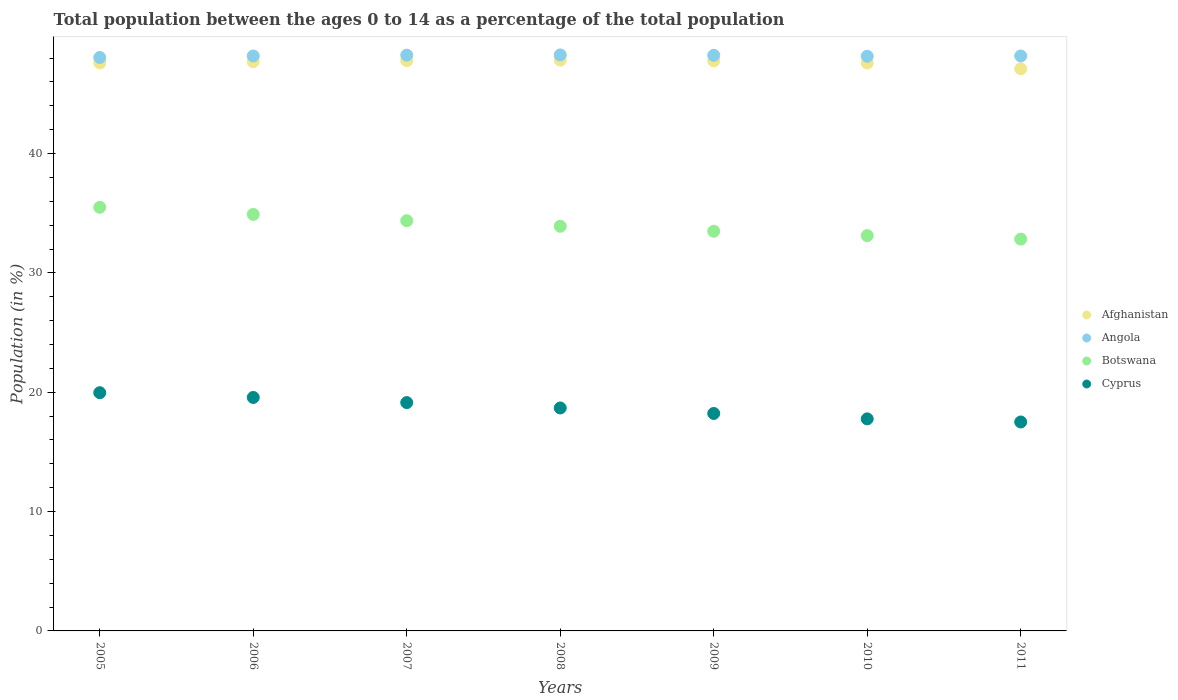What is the percentage of the population ages 0 to 14 in Botswana in 2006?
Your response must be concise. 34.9. Across all years, what is the maximum percentage of the population ages 0 to 14 in Angola?
Offer a terse response. 48.27. Across all years, what is the minimum percentage of the population ages 0 to 14 in Afghanistan?
Your answer should be compact. 47.1. What is the total percentage of the population ages 0 to 14 in Botswana in the graph?
Make the answer very short. 238.13. What is the difference between the percentage of the population ages 0 to 14 in Angola in 2006 and that in 2010?
Give a very brief answer. 0.03. What is the difference between the percentage of the population ages 0 to 14 in Cyprus in 2010 and the percentage of the population ages 0 to 14 in Angola in 2007?
Provide a short and direct response. -30.48. What is the average percentage of the population ages 0 to 14 in Angola per year?
Give a very brief answer. 48.19. In the year 2006, what is the difference between the percentage of the population ages 0 to 14 in Afghanistan and percentage of the population ages 0 to 14 in Botswana?
Your answer should be compact. 12.8. What is the ratio of the percentage of the population ages 0 to 14 in Botswana in 2005 to that in 2010?
Give a very brief answer. 1.07. Is the difference between the percentage of the population ages 0 to 14 in Afghanistan in 2010 and 2011 greater than the difference between the percentage of the population ages 0 to 14 in Botswana in 2010 and 2011?
Keep it short and to the point. Yes. What is the difference between the highest and the second highest percentage of the population ages 0 to 14 in Afghanistan?
Keep it short and to the point. 0.04. What is the difference between the highest and the lowest percentage of the population ages 0 to 14 in Botswana?
Make the answer very short. 2.67. Is the sum of the percentage of the population ages 0 to 14 in Botswana in 2008 and 2009 greater than the maximum percentage of the population ages 0 to 14 in Afghanistan across all years?
Your response must be concise. Yes. Is it the case that in every year, the sum of the percentage of the population ages 0 to 14 in Angola and percentage of the population ages 0 to 14 in Cyprus  is greater than the sum of percentage of the population ages 0 to 14 in Botswana and percentage of the population ages 0 to 14 in Afghanistan?
Offer a terse response. No. Is the percentage of the population ages 0 to 14 in Cyprus strictly greater than the percentage of the population ages 0 to 14 in Afghanistan over the years?
Offer a very short reply. No. Is the percentage of the population ages 0 to 14 in Afghanistan strictly less than the percentage of the population ages 0 to 14 in Angola over the years?
Your answer should be compact. Yes. How many years are there in the graph?
Provide a short and direct response. 7. What is the difference between two consecutive major ticks on the Y-axis?
Make the answer very short. 10. Are the values on the major ticks of Y-axis written in scientific E-notation?
Keep it short and to the point. No. Where does the legend appear in the graph?
Give a very brief answer. Center right. How many legend labels are there?
Offer a very short reply. 4. How are the legend labels stacked?
Make the answer very short. Vertical. What is the title of the graph?
Make the answer very short. Total population between the ages 0 to 14 as a percentage of the total population. What is the label or title of the X-axis?
Give a very brief answer. Years. What is the label or title of the Y-axis?
Provide a succinct answer. Population (in %). What is the Population (in %) in Afghanistan in 2005?
Your response must be concise. 47.59. What is the Population (in %) of Angola in 2005?
Provide a short and direct response. 48.05. What is the Population (in %) in Botswana in 2005?
Offer a very short reply. 35.5. What is the Population (in %) in Cyprus in 2005?
Keep it short and to the point. 19.96. What is the Population (in %) in Afghanistan in 2006?
Offer a very short reply. 47.7. What is the Population (in %) of Angola in 2006?
Ensure brevity in your answer.  48.18. What is the Population (in %) in Botswana in 2006?
Offer a terse response. 34.9. What is the Population (in %) in Cyprus in 2006?
Provide a short and direct response. 19.56. What is the Population (in %) in Afghanistan in 2007?
Provide a succinct answer. 47.79. What is the Population (in %) in Angola in 2007?
Offer a very short reply. 48.25. What is the Population (in %) in Botswana in 2007?
Offer a very short reply. 34.37. What is the Population (in %) of Cyprus in 2007?
Offer a very short reply. 19.13. What is the Population (in %) in Afghanistan in 2008?
Make the answer very short. 47.83. What is the Population (in %) in Angola in 2008?
Provide a short and direct response. 48.27. What is the Population (in %) in Botswana in 2008?
Give a very brief answer. 33.91. What is the Population (in %) in Cyprus in 2008?
Your answer should be very brief. 18.68. What is the Population (in %) in Afghanistan in 2009?
Ensure brevity in your answer.  47.77. What is the Population (in %) in Angola in 2009?
Your answer should be compact. 48.23. What is the Population (in %) in Botswana in 2009?
Ensure brevity in your answer.  33.49. What is the Population (in %) of Cyprus in 2009?
Your answer should be compact. 18.22. What is the Population (in %) in Afghanistan in 2010?
Provide a succinct answer. 47.59. What is the Population (in %) in Angola in 2010?
Your answer should be compact. 48.15. What is the Population (in %) of Botswana in 2010?
Ensure brevity in your answer.  33.12. What is the Population (in %) of Cyprus in 2010?
Provide a succinct answer. 17.77. What is the Population (in %) of Afghanistan in 2011?
Provide a succinct answer. 47.1. What is the Population (in %) in Angola in 2011?
Offer a very short reply. 48.18. What is the Population (in %) in Botswana in 2011?
Offer a terse response. 32.83. What is the Population (in %) of Cyprus in 2011?
Your response must be concise. 17.51. Across all years, what is the maximum Population (in %) of Afghanistan?
Provide a short and direct response. 47.83. Across all years, what is the maximum Population (in %) in Angola?
Offer a terse response. 48.27. Across all years, what is the maximum Population (in %) of Botswana?
Your response must be concise. 35.5. Across all years, what is the maximum Population (in %) in Cyprus?
Give a very brief answer. 19.96. Across all years, what is the minimum Population (in %) in Afghanistan?
Your answer should be very brief. 47.1. Across all years, what is the minimum Population (in %) of Angola?
Ensure brevity in your answer.  48.05. Across all years, what is the minimum Population (in %) of Botswana?
Make the answer very short. 32.83. Across all years, what is the minimum Population (in %) of Cyprus?
Offer a very short reply. 17.51. What is the total Population (in %) in Afghanistan in the graph?
Make the answer very short. 333.36. What is the total Population (in %) of Angola in the graph?
Ensure brevity in your answer.  337.31. What is the total Population (in %) in Botswana in the graph?
Your answer should be compact. 238.13. What is the total Population (in %) in Cyprus in the graph?
Your response must be concise. 130.84. What is the difference between the Population (in %) in Afghanistan in 2005 and that in 2006?
Keep it short and to the point. -0.1. What is the difference between the Population (in %) in Angola in 2005 and that in 2006?
Your response must be concise. -0.13. What is the difference between the Population (in %) of Botswana in 2005 and that in 2006?
Your response must be concise. 0.59. What is the difference between the Population (in %) in Cyprus in 2005 and that in 2006?
Offer a terse response. 0.4. What is the difference between the Population (in %) in Afghanistan in 2005 and that in 2007?
Offer a very short reply. -0.19. What is the difference between the Population (in %) in Angola in 2005 and that in 2007?
Your answer should be very brief. -0.2. What is the difference between the Population (in %) of Botswana in 2005 and that in 2007?
Ensure brevity in your answer.  1.12. What is the difference between the Population (in %) of Cyprus in 2005 and that in 2007?
Your answer should be very brief. 0.83. What is the difference between the Population (in %) of Afghanistan in 2005 and that in 2008?
Provide a short and direct response. -0.23. What is the difference between the Population (in %) in Angola in 2005 and that in 2008?
Give a very brief answer. -0.22. What is the difference between the Population (in %) in Botswana in 2005 and that in 2008?
Ensure brevity in your answer.  1.59. What is the difference between the Population (in %) of Cyprus in 2005 and that in 2008?
Offer a very short reply. 1.28. What is the difference between the Population (in %) of Afghanistan in 2005 and that in 2009?
Your answer should be compact. -0.17. What is the difference between the Population (in %) in Angola in 2005 and that in 2009?
Offer a very short reply. -0.18. What is the difference between the Population (in %) of Botswana in 2005 and that in 2009?
Your response must be concise. 2. What is the difference between the Population (in %) of Cyprus in 2005 and that in 2009?
Give a very brief answer. 1.74. What is the difference between the Population (in %) of Afghanistan in 2005 and that in 2010?
Offer a terse response. 0. What is the difference between the Population (in %) of Angola in 2005 and that in 2010?
Ensure brevity in your answer.  -0.1. What is the difference between the Population (in %) of Botswana in 2005 and that in 2010?
Provide a short and direct response. 2.37. What is the difference between the Population (in %) of Cyprus in 2005 and that in 2010?
Your answer should be very brief. 2.19. What is the difference between the Population (in %) in Afghanistan in 2005 and that in 2011?
Offer a terse response. 0.49. What is the difference between the Population (in %) of Angola in 2005 and that in 2011?
Give a very brief answer. -0.13. What is the difference between the Population (in %) in Botswana in 2005 and that in 2011?
Keep it short and to the point. 2.67. What is the difference between the Population (in %) of Cyprus in 2005 and that in 2011?
Keep it short and to the point. 2.45. What is the difference between the Population (in %) in Afghanistan in 2006 and that in 2007?
Offer a terse response. -0.09. What is the difference between the Population (in %) of Angola in 2006 and that in 2007?
Your answer should be very brief. -0.07. What is the difference between the Population (in %) in Botswana in 2006 and that in 2007?
Provide a short and direct response. 0.53. What is the difference between the Population (in %) of Cyprus in 2006 and that in 2007?
Offer a very short reply. 0.43. What is the difference between the Population (in %) of Afghanistan in 2006 and that in 2008?
Keep it short and to the point. -0.13. What is the difference between the Population (in %) in Angola in 2006 and that in 2008?
Keep it short and to the point. -0.09. What is the difference between the Population (in %) in Afghanistan in 2006 and that in 2009?
Make the answer very short. -0.07. What is the difference between the Population (in %) in Angola in 2006 and that in 2009?
Give a very brief answer. -0.06. What is the difference between the Population (in %) in Botswana in 2006 and that in 2009?
Offer a very short reply. 1.41. What is the difference between the Population (in %) in Cyprus in 2006 and that in 2009?
Give a very brief answer. 1.34. What is the difference between the Population (in %) in Afghanistan in 2006 and that in 2010?
Give a very brief answer. 0.11. What is the difference between the Population (in %) in Angola in 2006 and that in 2010?
Offer a very short reply. 0.03. What is the difference between the Population (in %) of Botswana in 2006 and that in 2010?
Provide a succinct answer. 1.78. What is the difference between the Population (in %) of Cyprus in 2006 and that in 2010?
Your response must be concise. 1.79. What is the difference between the Population (in %) of Afghanistan in 2006 and that in 2011?
Your answer should be compact. 0.6. What is the difference between the Population (in %) of Angola in 2006 and that in 2011?
Your answer should be compact. -0. What is the difference between the Population (in %) of Botswana in 2006 and that in 2011?
Provide a succinct answer. 2.07. What is the difference between the Population (in %) in Cyprus in 2006 and that in 2011?
Offer a terse response. 2.05. What is the difference between the Population (in %) in Afghanistan in 2007 and that in 2008?
Offer a very short reply. -0.04. What is the difference between the Population (in %) of Angola in 2007 and that in 2008?
Give a very brief answer. -0.02. What is the difference between the Population (in %) of Botswana in 2007 and that in 2008?
Your response must be concise. 0.47. What is the difference between the Population (in %) of Cyprus in 2007 and that in 2008?
Your response must be concise. 0.45. What is the difference between the Population (in %) of Afghanistan in 2007 and that in 2009?
Your answer should be very brief. 0.02. What is the difference between the Population (in %) of Angola in 2007 and that in 2009?
Your answer should be compact. 0.01. What is the difference between the Population (in %) in Botswana in 2007 and that in 2009?
Keep it short and to the point. 0.88. What is the difference between the Population (in %) in Cyprus in 2007 and that in 2009?
Your response must be concise. 0.91. What is the difference between the Population (in %) of Afghanistan in 2007 and that in 2010?
Offer a terse response. 0.2. What is the difference between the Population (in %) of Angola in 2007 and that in 2010?
Your answer should be compact. 0.1. What is the difference between the Population (in %) in Botswana in 2007 and that in 2010?
Your response must be concise. 1.25. What is the difference between the Population (in %) of Cyprus in 2007 and that in 2010?
Offer a terse response. 1.36. What is the difference between the Population (in %) of Afghanistan in 2007 and that in 2011?
Your answer should be very brief. 0.69. What is the difference between the Population (in %) in Angola in 2007 and that in 2011?
Provide a short and direct response. 0.07. What is the difference between the Population (in %) in Botswana in 2007 and that in 2011?
Ensure brevity in your answer.  1.54. What is the difference between the Population (in %) of Cyprus in 2007 and that in 2011?
Offer a very short reply. 1.62. What is the difference between the Population (in %) in Afghanistan in 2008 and that in 2009?
Give a very brief answer. 0.06. What is the difference between the Population (in %) in Angola in 2008 and that in 2009?
Give a very brief answer. 0.03. What is the difference between the Population (in %) in Botswana in 2008 and that in 2009?
Your response must be concise. 0.42. What is the difference between the Population (in %) in Cyprus in 2008 and that in 2009?
Provide a succinct answer. 0.46. What is the difference between the Population (in %) of Afghanistan in 2008 and that in 2010?
Make the answer very short. 0.24. What is the difference between the Population (in %) of Angola in 2008 and that in 2010?
Your answer should be very brief. 0.11. What is the difference between the Population (in %) of Botswana in 2008 and that in 2010?
Offer a terse response. 0.78. What is the difference between the Population (in %) in Cyprus in 2008 and that in 2010?
Your answer should be compact. 0.91. What is the difference between the Population (in %) of Afghanistan in 2008 and that in 2011?
Your answer should be very brief. 0.72. What is the difference between the Population (in %) in Angola in 2008 and that in 2011?
Keep it short and to the point. 0.09. What is the difference between the Population (in %) of Botswana in 2008 and that in 2011?
Your response must be concise. 1.08. What is the difference between the Population (in %) of Cyprus in 2008 and that in 2011?
Ensure brevity in your answer.  1.17. What is the difference between the Population (in %) of Afghanistan in 2009 and that in 2010?
Provide a short and direct response. 0.18. What is the difference between the Population (in %) of Angola in 2009 and that in 2010?
Your answer should be compact. 0.08. What is the difference between the Population (in %) of Botswana in 2009 and that in 2010?
Your response must be concise. 0.37. What is the difference between the Population (in %) in Cyprus in 2009 and that in 2010?
Provide a succinct answer. 0.45. What is the difference between the Population (in %) in Afghanistan in 2009 and that in 2011?
Your answer should be very brief. 0.67. What is the difference between the Population (in %) in Angola in 2009 and that in 2011?
Give a very brief answer. 0.05. What is the difference between the Population (in %) of Botswana in 2009 and that in 2011?
Provide a succinct answer. 0.66. What is the difference between the Population (in %) of Cyprus in 2009 and that in 2011?
Provide a succinct answer. 0.71. What is the difference between the Population (in %) in Afghanistan in 2010 and that in 2011?
Give a very brief answer. 0.49. What is the difference between the Population (in %) of Angola in 2010 and that in 2011?
Keep it short and to the point. -0.03. What is the difference between the Population (in %) in Botswana in 2010 and that in 2011?
Your response must be concise. 0.29. What is the difference between the Population (in %) in Cyprus in 2010 and that in 2011?
Give a very brief answer. 0.26. What is the difference between the Population (in %) of Afghanistan in 2005 and the Population (in %) of Angola in 2006?
Your response must be concise. -0.59. What is the difference between the Population (in %) in Afghanistan in 2005 and the Population (in %) in Botswana in 2006?
Give a very brief answer. 12.69. What is the difference between the Population (in %) in Afghanistan in 2005 and the Population (in %) in Cyprus in 2006?
Keep it short and to the point. 28.03. What is the difference between the Population (in %) of Angola in 2005 and the Population (in %) of Botswana in 2006?
Make the answer very short. 13.15. What is the difference between the Population (in %) in Angola in 2005 and the Population (in %) in Cyprus in 2006?
Ensure brevity in your answer.  28.49. What is the difference between the Population (in %) in Botswana in 2005 and the Population (in %) in Cyprus in 2006?
Provide a short and direct response. 15.93. What is the difference between the Population (in %) of Afghanistan in 2005 and the Population (in %) of Angola in 2007?
Your answer should be compact. -0.66. What is the difference between the Population (in %) in Afghanistan in 2005 and the Population (in %) in Botswana in 2007?
Your response must be concise. 13.22. What is the difference between the Population (in %) of Afghanistan in 2005 and the Population (in %) of Cyprus in 2007?
Offer a terse response. 28.46. What is the difference between the Population (in %) of Angola in 2005 and the Population (in %) of Botswana in 2007?
Provide a short and direct response. 13.68. What is the difference between the Population (in %) of Angola in 2005 and the Population (in %) of Cyprus in 2007?
Make the answer very short. 28.92. What is the difference between the Population (in %) of Botswana in 2005 and the Population (in %) of Cyprus in 2007?
Your answer should be compact. 16.36. What is the difference between the Population (in %) of Afghanistan in 2005 and the Population (in %) of Angola in 2008?
Your response must be concise. -0.67. What is the difference between the Population (in %) in Afghanistan in 2005 and the Population (in %) in Botswana in 2008?
Your response must be concise. 13.69. What is the difference between the Population (in %) of Afghanistan in 2005 and the Population (in %) of Cyprus in 2008?
Give a very brief answer. 28.91. What is the difference between the Population (in %) of Angola in 2005 and the Population (in %) of Botswana in 2008?
Provide a short and direct response. 14.14. What is the difference between the Population (in %) in Angola in 2005 and the Population (in %) in Cyprus in 2008?
Give a very brief answer. 29.37. What is the difference between the Population (in %) in Botswana in 2005 and the Population (in %) in Cyprus in 2008?
Provide a short and direct response. 16.81. What is the difference between the Population (in %) in Afghanistan in 2005 and the Population (in %) in Angola in 2009?
Make the answer very short. -0.64. What is the difference between the Population (in %) in Afghanistan in 2005 and the Population (in %) in Botswana in 2009?
Offer a very short reply. 14.1. What is the difference between the Population (in %) of Afghanistan in 2005 and the Population (in %) of Cyprus in 2009?
Your response must be concise. 29.37. What is the difference between the Population (in %) of Angola in 2005 and the Population (in %) of Botswana in 2009?
Your answer should be compact. 14.56. What is the difference between the Population (in %) in Angola in 2005 and the Population (in %) in Cyprus in 2009?
Provide a succinct answer. 29.83. What is the difference between the Population (in %) of Botswana in 2005 and the Population (in %) of Cyprus in 2009?
Give a very brief answer. 17.27. What is the difference between the Population (in %) of Afghanistan in 2005 and the Population (in %) of Angola in 2010?
Provide a short and direct response. -0.56. What is the difference between the Population (in %) of Afghanistan in 2005 and the Population (in %) of Botswana in 2010?
Your answer should be compact. 14.47. What is the difference between the Population (in %) of Afghanistan in 2005 and the Population (in %) of Cyprus in 2010?
Offer a very short reply. 29.82. What is the difference between the Population (in %) in Angola in 2005 and the Population (in %) in Botswana in 2010?
Make the answer very short. 14.93. What is the difference between the Population (in %) of Angola in 2005 and the Population (in %) of Cyprus in 2010?
Make the answer very short. 30.28. What is the difference between the Population (in %) of Botswana in 2005 and the Population (in %) of Cyprus in 2010?
Keep it short and to the point. 17.73. What is the difference between the Population (in %) in Afghanistan in 2005 and the Population (in %) in Angola in 2011?
Your answer should be compact. -0.59. What is the difference between the Population (in %) of Afghanistan in 2005 and the Population (in %) of Botswana in 2011?
Provide a short and direct response. 14.76. What is the difference between the Population (in %) of Afghanistan in 2005 and the Population (in %) of Cyprus in 2011?
Offer a terse response. 30.08. What is the difference between the Population (in %) of Angola in 2005 and the Population (in %) of Botswana in 2011?
Keep it short and to the point. 15.22. What is the difference between the Population (in %) in Angola in 2005 and the Population (in %) in Cyprus in 2011?
Provide a short and direct response. 30.54. What is the difference between the Population (in %) in Botswana in 2005 and the Population (in %) in Cyprus in 2011?
Provide a short and direct response. 17.99. What is the difference between the Population (in %) in Afghanistan in 2006 and the Population (in %) in Angola in 2007?
Offer a terse response. -0.55. What is the difference between the Population (in %) of Afghanistan in 2006 and the Population (in %) of Botswana in 2007?
Keep it short and to the point. 13.32. What is the difference between the Population (in %) of Afghanistan in 2006 and the Population (in %) of Cyprus in 2007?
Your answer should be very brief. 28.56. What is the difference between the Population (in %) in Angola in 2006 and the Population (in %) in Botswana in 2007?
Your response must be concise. 13.8. What is the difference between the Population (in %) in Angola in 2006 and the Population (in %) in Cyprus in 2007?
Offer a very short reply. 29.04. What is the difference between the Population (in %) of Botswana in 2006 and the Population (in %) of Cyprus in 2007?
Your answer should be compact. 15.77. What is the difference between the Population (in %) in Afghanistan in 2006 and the Population (in %) in Angola in 2008?
Offer a very short reply. -0.57. What is the difference between the Population (in %) of Afghanistan in 2006 and the Population (in %) of Botswana in 2008?
Your answer should be compact. 13.79. What is the difference between the Population (in %) in Afghanistan in 2006 and the Population (in %) in Cyprus in 2008?
Keep it short and to the point. 29.01. What is the difference between the Population (in %) of Angola in 2006 and the Population (in %) of Botswana in 2008?
Keep it short and to the point. 14.27. What is the difference between the Population (in %) in Angola in 2006 and the Population (in %) in Cyprus in 2008?
Offer a terse response. 29.49. What is the difference between the Population (in %) of Botswana in 2006 and the Population (in %) of Cyprus in 2008?
Ensure brevity in your answer.  16.22. What is the difference between the Population (in %) of Afghanistan in 2006 and the Population (in %) of Angola in 2009?
Keep it short and to the point. -0.54. What is the difference between the Population (in %) in Afghanistan in 2006 and the Population (in %) in Botswana in 2009?
Provide a short and direct response. 14.2. What is the difference between the Population (in %) in Afghanistan in 2006 and the Population (in %) in Cyprus in 2009?
Keep it short and to the point. 29.47. What is the difference between the Population (in %) of Angola in 2006 and the Population (in %) of Botswana in 2009?
Offer a very short reply. 14.69. What is the difference between the Population (in %) of Angola in 2006 and the Population (in %) of Cyprus in 2009?
Ensure brevity in your answer.  29.96. What is the difference between the Population (in %) in Botswana in 2006 and the Population (in %) in Cyprus in 2009?
Provide a succinct answer. 16.68. What is the difference between the Population (in %) in Afghanistan in 2006 and the Population (in %) in Angola in 2010?
Offer a terse response. -0.46. What is the difference between the Population (in %) in Afghanistan in 2006 and the Population (in %) in Botswana in 2010?
Offer a terse response. 14.57. What is the difference between the Population (in %) of Afghanistan in 2006 and the Population (in %) of Cyprus in 2010?
Keep it short and to the point. 29.93. What is the difference between the Population (in %) of Angola in 2006 and the Population (in %) of Botswana in 2010?
Offer a very short reply. 15.05. What is the difference between the Population (in %) of Angola in 2006 and the Population (in %) of Cyprus in 2010?
Your response must be concise. 30.41. What is the difference between the Population (in %) in Botswana in 2006 and the Population (in %) in Cyprus in 2010?
Provide a succinct answer. 17.13. What is the difference between the Population (in %) in Afghanistan in 2006 and the Population (in %) in Angola in 2011?
Provide a short and direct response. -0.48. What is the difference between the Population (in %) of Afghanistan in 2006 and the Population (in %) of Botswana in 2011?
Keep it short and to the point. 14.87. What is the difference between the Population (in %) of Afghanistan in 2006 and the Population (in %) of Cyprus in 2011?
Offer a terse response. 30.19. What is the difference between the Population (in %) of Angola in 2006 and the Population (in %) of Botswana in 2011?
Your response must be concise. 15.35. What is the difference between the Population (in %) of Angola in 2006 and the Population (in %) of Cyprus in 2011?
Your answer should be very brief. 30.67. What is the difference between the Population (in %) of Botswana in 2006 and the Population (in %) of Cyprus in 2011?
Ensure brevity in your answer.  17.39. What is the difference between the Population (in %) in Afghanistan in 2007 and the Population (in %) in Angola in 2008?
Offer a terse response. -0.48. What is the difference between the Population (in %) of Afghanistan in 2007 and the Population (in %) of Botswana in 2008?
Your response must be concise. 13.88. What is the difference between the Population (in %) of Afghanistan in 2007 and the Population (in %) of Cyprus in 2008?
Give a very brief answer. 29.1. What is the difference between the Population (in %) of Angola in 2007 and the Population (in %) of Botswana in 2008?
Keep it short and to the point. 14.34. What is the difference between the Population (in %) of Angola in 2007 and the Population (in %) of Cyprus in 2008?
Your answer should be compact. 29.57. What is the difference between the Population (in %) of Botswana in 2007 and the Population (in %) of Cyprus in 2008?
Provide a short and direct response. 15.69. What is the difference between the Population (in %) of Afghanistan in 2007 and the Population (in %) of Angola in 2009?
Your answer should be compact. -0.45. What is the difference between the Population (in %) of Afghanistan in 2007 and the Population (in %) of Botswana in 2009?
Offer a terse response. 14.29. What is the difference between the Population (in %) in Afghanistan in 2007 and the Population (in %) in Cyprus in 2009?
Your answer should be compact. 29.56. What is the difference between the Population (in %) in Angola in 2007 and the Population (in %) in Botswana in 2009?
Your answer should be compact. 14.76. What is the difference between the Population (in %) of Angola in 2007 and the Population (in %) of Cyprus in 2009?
Your answer should be compact. 30.03. What is the difference between the Population (in %) in Botswana in 2007 and the Population (in %) in Cyprus in 2009?
Your answer should be very brief. 16.15. What is the difference between the Population (in %) of Afghanistan in 2007 and the Population (in %) of Angola in 2010?
Provide a succinct answer. -0.37. What is the difference between the Population (in %) in Afghanistan in 2007 and the Population (in %) in Botswana in 2010?
Provide a succinct answer. 14.66. What is the difference between the Population (in %) in Afghanistan in 2007 and the Population (in %) in Cyprus in 2010?
Offer a very short reply. 30.02. What is the difference between the Population (in %) of Angola in 2007 and the Population (in %) of Botswana in 2010?
Offer a very short reply. 15.12. What is the difference between the Population (in %) in Angola in 2007 and the Population (in %) in Cyprus in 2010?
Give a very brief answer. 30.48. What is the difference between the Population (in %) in Botswana in 2007 and the Population (in %) in Cyprus in 2010?
Provide a short and direct response. 16.61. What is the difference between the Population (in %) in Afghanistan in 2007 and the Population (in %) in Angola in 2011?
Ensure brevity in your answer.  -0.39. What is the difference between the Population (in %) of Afghanistan in 2007 and the Population (in %) of Botswana in 2011?
Offer a very short reply. 14.96. What is the difference between the Population (in %) in Afghanistan in 2007 and the Population (in %) in Cyprus in 2011?
Offer a terse response. 30.28. What is the difference between the Population (in %) of Angola in 2007 and the Population (in %) of Botswana in 2011?
Give a very brief answer. 15.42. What is the difference between the Population (in %) of Angola in 2007 and the Population (in %) of Cyprus in 2011?
Provide a succinct answer. 30.74. What is the difference between the Population (in %) of Botswana in 2007 and the Population (in %) of Cyprus in 2011?
Your answer should be compact. 16.87. What is the difference between the Population (in %) of Afghanistan in 2008 and the Population (in %) of Angola in 2009?
Give a very brief answer. -0.41. What is the difference between the Population (in %) in Afghanistan in 2008 and the Population (in %) in Botswana in 2009?
Your answer should be compact. 14.33. What is the difference between the Population (in %) of Afghanistan in 2008 and the Population (in %) of Cyprus in 2009?
Offer a very short reply. 29.6. What is the difference between the Population (in %) in Angola in 2008 and the Population (in %) in Botswana in 2009?
Ensure brevity in your answer.  14.77. What is the difference between the Population (in %) in Angola in 2008 and the Population (in %) in Cyprus in 2009?
Provide a succinct answer. 30.04. What is the difference between the Population (in %) of Botswana in 2008 and the Population (in %) of Cyprus in 2009?
Your answer should be compact. 15.68. What is the difference between the Population (in %) of Afghanistan in 2008 and the Population (in %) of Angola in 2010?
Make the answer very short. -0.33. What is the difference between the Population (in %) of Afghanistan in 2008 and the Population (in %) of Botswana in 2010?
Your response must be concise. 14.7. What is the difference between the Population (in %) in Afghanistan in 2008 and the Population (in %) in Cyprus in 2010?
Your answer should be very brief. 30.06. What is the difference between the Population (in %) in Angola in 2008 and the Population (in %) in Botswana in 2010?
Ensure brevity in your answer.  15.14. What is the difference between the Population (in %) of Angola in 2008 and the Population (in %) of Cyprus in 2010?
Make the answer very short. 30.5. What is the difference between the Population (in %) in Botswana in 2008 and the Population (in %) in Cyprus in 2010?
Make the answer very short. 16.14. What is the difference between the Population (in %) in Afghanistan in 2008 and the Population (in %) in Angola in 2011?
Your answer should be very brief. -0.35. What is the difference between the Population (in %) in Afghanistan in 2008 and the Population (in %) in Botswana in 2011?
Keep it short and to the point. 15. What is the difference between the Population (in %) of Afghanistan in 2008 and the Population (in %) of Cyprus in 2011?
Keep it short and to the point. 30.32. What is the difference between the Population (in %) in Angola in 2008 and the Population (in %) in Botswana in 2011?
Make the answer very short. 15.44. What is the difference between the Population (in %) in Angola in 2008 and the Population (in %) in Cyprus in 2011?
Your answer should be very brief. 30.76. What is the difference between the Population (in %) of Botswana in 2008 and the Population (in %) of Cyprus in 2011?
Ensure brevity in your answer.  16.4. What is the difference between the Population (in %) in Afghanistan in 2009 and the Population (in %) in Angola in 2010?
Your response must be concise. -0.39. What is the difference between the Population (in %) of Afghanistan in 2009 and the Population (in %) of Botswana in 2010?
Give a very brief answer. 14.64. What is the difference between the Population (in %) of Afghanistan in 2009 and the Population (in %) of Cyprus in 2010?
Keep it short and to the point. 30. What is the difference between the Population (in %) of Angola in 2009 and the Population (in %) of Botswana in 2010?
Offer a very short reply. 15.11. What is the difference between the Population (in %) of Angola in 2009 and the Population (in %) of Cyprus in 2010?
Your response must be concise. 30.46. What is the difference between the Population (in %) in Botswana in 2009 and the Population (in %) in Cyprus in 2010?
Your answer should be compact. 15.72. What is the difference between the Population (in %) in Afghanistan in 2009 and the Population (in %) in Angola in 2011?
Provide a short and direct response. -0.41. What is the difference between the Population (in %) in Afghanistan in 2009 and the Population (in %) in Botswana in 2011?
Your response must be concise. 14.94. What is the difference between the Population (in %) of Afghanistan in 2009 and the Population (in %) of Cyprus in 2011?
Ensure brevity in your answer.  30.26. What is the difference between the Population (in %) of Angola in 2009 and the Population (in %) of Botswana in 2011?
Give a very brief answer. 15.4. What is the difference between the Population (in %) in Angola in 2009 and the Population (in %) in Cyprus in 2011?
Provide a succinct answer. 30.72. What is the difference between the Population (in %) in Botswana in 2009 and the Population (in %) in Cyprus in 2011?
Ensure brevity in your answer.  15.98. What is the difference between the Population (in %) in Afghanistan in 2010 and the Population (in %) in Angola in 2011?
Provide a succinct answer. -0.59. What is the difference between the Population (in %) of Afghanistan in 2010 and the Population (in %) of Botswana in 2011?
Offer a very short reply. 14.76. What is the difference between the Population (in %) in Afghanistan in 2010 and the Population (in %) in Cyprus in 2011?
Make the answer very short. 30.08. What is the difference between the Population (in %) of Angola in 2010 and the Population (in %) of Botswana in 2011?
Keep it short and to the point. 15.32. What is the difference between the Population (in %) of Angola in 2010 and the Population (in %) of Cyprus in 2011?
Offer a very short reply. 30.64. What is the difference between the Population (in %) in Botswana in 2010 and the Population (in %) in Cyprus in 2011?
Keep it short and to the point. 15.62. What is the average Population (in %) in Afghanistan per year?
Offer a terse response. 47.62. What is the average Population (in %) of Angola per year?
Provide a succinct answer. 48.19. What is the average Population (in %) of Botswana per year?
Provide a succinct answer. 34.02. What is the average Population (in %) of Cyprus per year?
Offer a very short reply. 18.69. In the year 2005, what is the difference between the Population (in %) of Afghanistan and Population (in %) of Angola?
Offer a very short reply. -0.46. In the year 2005, what is the difference between the Population (in %) in Afghanistan and Population (in %) in Botswana?
Provide a succinct answer. 12.1. In the year 2005, what is the difference between the Population (in %) of Afghanistan and Population (in %) of Cyprus?
Offer a terse response. 27.63. In the year 2005, what is the difference between the Population (in %) of Angola and Population (in %) of Botswana?
Your answer should be compact. 12.55. In the year 2005, what is the difference between the Population (in %) of Angola and Population (in %) of Cyprus?
Offer a terse response. 28.09. In the year 2005, what is the difference between the Population (in %) in Botswana and Population (in %) in Cyprus?
Give a very brief answer. 15.53. In the year 2006, what is the difference between the Population (in %) of Afghanistan and Population (in %) of Angola?
Provide a short and direct response. -0.48. In the year 2006, what is the difference between the Population (in %) in Afghanistan and Population (in %) in Botswana?
Your answer should be compact. 12.79. In the year 2006, what is the difference between the Population (in %) in Afghanistan and Population (in %) in Cyprus?
Keep it short and to the point. 28.13. In the year 2006, what is the difference between the Population (in %) in Angola and Population (in %) in Botswana?
Your response must be concise. 13.28. In the year 2006, what is the difference between the Population (in %) in Angola and Population (in %) in Cyprus?
Offer a very short reply. 28.61. In the year 2006, what is the difference between the Population (in %) in Botswana and Population (in %) in Cyprus?
Provide a short and direct response. 15.34. In the year 2007, what is the difference between the Population (in %) of Afghanistan and Population (in %) of Angola?
Offer a terse response. -0.46. In the year 2007, what is the difference between the Population (in %) of Afghanistan and Population (in %) of Botswana?
Ensure brevity in your answer.  13.41. In the year 2007, what is the difference between the Population (in %) in Afghanistan and Population (in %) in Cyprus?
Make the answer very short. 28.65. In the year 2007, what is the difference between the Population (in %) in Angola and Population (in %) in Botswana?
Offer a very short reply. 13.87. In the year 2007, what is the difference between the Population (in %) in Angola and Population (in %) in Cyprus?
Provide a short and direct response. 29.11. In the year 2007, what is the difference between the Population (in %) in Botswana and Population (in %) in Cyprus?
Give a very brief answer. 15.24. In the year 2008, what is the difference between the Population (in %) in Afghanistan and Population (in %) in Angola?
Your answer should be very brief. -0.44. In the year 2008, what is the difference between the Population (in %) of Afghanistan and Population (in %) of Botswana?
Your answer should be very brief. 13.92. In the year 2008, what is the difference between the Population (in %) of Afghanistan and Population (in %) of Cyprus?
Offer a terse response. 29.14. In the year 2008, what is the difference between the Population (in %) of Angola and Population (in %) of Botswana?
Offer a very short reply. 14.36. In the year 2008, what is the difference between the Population (in %) in Angola and Population (in %) in Cyprus?
Ensure brevity in your answer.  29.58. In the year 2008, what is the difference between the Population (in %) in Botswana and Population (in %) in Cyprus?
Your answer should be compact. 15.22. In the year 2009, what is the difference between the Population (in %) of Afghanistan and Population (in %) of Angola?
Provide a succinct answer. -0.47. In the year 2009, what is the difference between the Population (in %) of Afghanistan and Population (in %) of Botswana?
Make the answer very short. 14.27. In the year 2009, what is the difference between the Population (in %) in Afghanistan and Population (in %) in Cyprus?
Offer a terse response. 29.54. In the year 2009, what is the difference between the Population (in %) of Angola and Population (in %) of Botswana?
Your answer should be very brief. 14.74. In the year 2009, what is the difference between the Population (in %) of Angola and Population (in %) of Cyprus?
Offer a very short reply. 30.01. In the year 2009, what is the difference between the Population (in %) in Botswana and Population (in %) in Cyprus?
Your answer should be compact. 15.27. In the year 2010, what is the difference between the Population (in %) in Afghanistan and Population (in %) in Angola?
Provide a short and direct response. -0.56. In the year 2010, what is the difference between the Population (in %) of Afghanistan and Population (in %) of Botswana?
Provide a succinct answer. 14.46. In the year 2010, what is the difference between the Population (in %) in Afghanistan and Population (in %) in Cyprus?
Offer a terse response. 29.82. In the year 2010, what is the difference between the Population (in %) of Angola and Population (in %) of Botswana?
Offer a terse response. 15.03. In the year 2010, what is the difference between the Population (in %) of Angola and Population (in %) of Cyprus?
Provide a succinct answer. 30.38. In the year 2010, what is the difference between the Population (in %) of Botswana and Population (in %) of Cyprus?
Your response must be concise. 15.36. In the year 2011, what is the difference between the Population (in %) in Afghanistan and Population (in %) in Angola?
Provide a short and direct response. -1.08. In the year 2011, what is the difference between the Population (in %) of Afghanistan and Population (in %) of Botswana?
Provide a short and direct response. 14.27. In the year 2011, what is the difference between the Population (in %) of Afghanistan and Population (in %) of Cyprus?
Offer a very short reply. 29.59. In the year 2011, what is the difference between the Population (in %) in Angola and Population (in %) in Botswana?
Ensure brevity in your answer.  15.35. In the year 2011, what is the difference between the Population (in %) of Angola and Population (in %) of Cyprus?
Keep it short and to the point. 30.67. In the year 2011, what is the difference between the Population (in %) of Botswana and Population (in %) of Cyprus?
Offer a very short reply. 15.32. What is the ratio of the Population (in %) in Afghanistan in 2005 to that in 2006?
Make the answer very short. 1. What is the ratio of the Population (in %) of Angola in 2005 to that in 2006?
Keep it short and to the point. 1. What is the ratio of the Population (in %) of Cyprus in 2005 to that in 2006?
Keep it short and to the point. 1.02. What is the ratio of the Population (in %) of Botswana in 2005 to that in 2007?
Offer a very short reply. 1.03. What is the ratio of the Population (in %) in Cyprus in 2005 to that in 2007?
Your answer should be very brief. 1.04. What is the ratio of the Population (in %) in Angola in 2005 to that in 2008?
Provide a short and direct response. 1. What is the ratio of the Population (in %) in Botswana in 2005 to that in 2008?
Your answer should be compact. 1.05. What is the ratio of the Population (in %) in Cyprus in 2005 to that in 2008?
Your answer should be compact. 1.07. What is the ratio of the Population (in %) in Botswana in 2005 to that in 2009?
Give a very brief answer. 1.06. What is the ratio of the Population (in %) of Cyprus in 2005 to that in 2009?
Keep it short and to the point. 1.1. What is the ratio of the Population (in %) of Afghanistan in 2005 to that in 2010?
Your answer should be compact. 1. What is the ratio of the Population (in %) of Angola in 2005 to that in 2010?
Offer a very short reply. 1. What is the ratio of the Population (in %) in Botswana in 2005 to that in 2010?
Provide a short and direct response. 1.07. What is the ratio of the Population (in %) in Cyprus in 2005 to that in 2010?
Your response must be concise. 1.12. What is the ratio of the Population (in %) of Afghanistan in 2005 to that in 2011?
Offer a terse response. 1.01. What is the ratio of the Population (in %) in Angola in 2005 to that in 2011?
Your answer should be very brief. 1. What is the ratio of the Population (in %) of Botswana in 2005 to that in 2011?
Your answer should be very brief. 1.08. What is the ratio of the Population (in %) of Cyprus in 2005 to that in 2011?
Make the answer very short. 1.14. What is the ratio of the Population (in %) of Angola in 2006 to that in 2007?
Offer a terse response. 1. What is the ratio of the Population (in %) in Botswana in 2006 to that in 2007?
Offer a very short reply. 1.02. What is the ratio of the Population (in %) in Cyprus in 2006 to that in 2007?
Offer a terse response. 1.02. What is the ratio of the Population (in %) in Afghanistan in 2006 to that in 2008?
Ensure brevity in your answer.  1. What is the ratio of the Population (in %) in Botswana in 2006 to that in 2008?
Make the answer very short. 1.03. What is the ratio of the Population (in %) in Cyprus in 2006 to that in 2008?
Ensure brevity in your answer.  1.05. What is the ratio of the Population (in %) in Angola in 2006 to that in 2009?
Your answer should be compact. 1. What is the ratio of the Population (in %) in Botswana in 2006 to that in 2009?
Provide a succinct answer. 1.04. What is the ratio of the Population (in %) in Cyprus in 2006 to that in 2009?
Your answer should be compact. 1.07. What is the ratio of the Population (in %) in Angola in 2006 to that in 2010?
Your answer should be compact. 1. What is the ratio of the Population (in %) in Botswana in 2006 to that in 2010?
Make the answer very short. 1.05. What is the ratio of the Population (in %) of Cyprus in 2006 to that in 2010?
Ensure brevity in your answer.  1.1. What is the ratio of the Population (in %) in Afghanistan in 2006 to that in 2011?
Provide a succinct answer. 1.01. What is the ratio of the Population (in %) of Angola in 2006 to that in 2011?
Provide a succinct answer. 1. What is the ratio of the Population (in %) in Botswana in 2006 to that in 2011?
Make the answer very short. 1.06. What is the ratio of the Population (in %) in Cyprus in 2006 to that in 2011?
Your response must be concise. 1.12. What is the ratio of the Population (in %) in Afghanistan in 2007 to that in 2008?
Provide a short and direct response. 1. What is the ratio of the Population (in %) of Angola in 2007 to that in 2008?
Ensure brevity in your answer.  1. What is the ratio of the Population (in %) in Botswana in 2007 to that in 2008?
Provide a short and direct response. 1.01. What is the ratio of the Population (in %) in Cyprus in 2007 to that in 2008?
Provide a succinct answer. 1.02. What is the ratio of the Population (in %) of Afghanistan in 2007 to that in 2009?
Provide a succinct answer. 1. What is the ratio of the Population (in %) of Angola in 2007 to that in 2009?
Keep it short and to the point. 1. What is the ratio of the Population (in %) in Botswana in 2007 to that in 2009?
Make the answer very short. 1.03. What is the ratio of the Population (in %) of Botswana in 2007 to that in 2010?
Provide a succinct answer. 1.04. What is the ratio of the Population (in %) in Cyprus in 2007 to that in 2010?
Provide a succinct answer. 1.08. What is the ratio of the Population (in %) in Afghanistan in 2007 to that in 2011?
Ensure brevity in your answer.  1.01. What is the ratio of the Population (in %) of Botswana in 2007 to that in 2011?
Your answer should be compact. 1.05. What is the ratio of the Population (in %) of Cyprus in 2007 to that in 2011?
Give a very brief answer. 1.09. What is the ratio of the Population (in %) in Afghanistan in 2008 to that in 2009?
Make the answer very short. 1. What is the ratio of the Population (in %) in Angola in 2008 to that in 2009?
Give a very brief answer. 1. What is the ratio of the Population (in %) of Botswana in 2008 to that in 2009?
Keep it short and to the point. 1.01. What is the ratio of the Population (in %) in Cyprus in 2008 to that in 2009?
Provide a short and direct response. 1.03. What is the ratio of the Population (in %) of Afghanistan in 2008 to that in 2010?
Your answer should be compact. 1. What is the ratio of the Population (in %) in Botswana in 2008 to that in 2010?
Give a very brief answer. 1.02. What is the ratio of the Population (in %) in Cyprus in 2008 to that in 2010?
Offer a terse response. 1.05. What is the ratio of the Population (in %) of Afghanistan in 2008 to that in 2011?
Keep it short and to the point. 1.02. What is the ratio of the Population (in %) of Botswana in 2008 to that in 2011?
Provide a short and direct response. 1.03. What is the ratio of the Population (in %) in Cyprus in 2008 to that in 2011?
Offer a terse response. 1.07. What is the ratio of the Population (in %) in Afghanistan in 2009 to that in 2010?
Offer a terse response. 1. What is the ratio of the Population (in %) in Angola in 2009 to that in 2010?
Give a very brief answer. 1. What is the ratio of the Population (in %) in Botswana in 2009 to that in 2010?
Offer a very short reply. 1.01. What is the ratio of the Population (in %) of Cyprus in 2009 to that in 2010?
Your response must be concise. 1.03. What is the ratio of the Population (in %) in Afghanistan in 2009 to that in 2011?
Make the answer very short. 1.01. What is the ratio of the Population (in %) in Botswana in 2009 to that in 2011?
Offer a terse response. 1.02. What is the ratio of the Population (in %) of Cyprus in 2009 to that in 2011?
Keep it short and to the point. 1.04. What is the ratio of the Population (in %) of Afghanistan in 2010 to that in 2011?
Keep it short and to the point. 1.01. What is the ratio of the Population (in %) of Angola in 2010 to that in 2011?
Make the answer very short. 1. What is the ratio of the Population (in %) of Cyprus in 2010 to that in 2011?
Your response must be concise. 1.01. What is the difference between the highest and the second highest Population (in %) of Afghanistan?
Ensure brevity in your answer.  0.04. What is the difference between the highest and the second highest Population (in %) of Angola?
Your response must be concise. 0.02. What is the difference between the highest and the second highest Population (in %) in Botswana?
Ensure brevity in your answer.  0.59. What is the difference between the highest and the second highest Population (in %) in Cyprus?
Give a very brief answer. 0.4. What is the difference between the highest and the lowest Population (in %) in Afghanistan?
Offer a terse response. 0.72. What is the difference between the highest and the lowest Population (in %) of Angola?
Provide a succinct answer. 0.22. What is the difference between the highest and the lowest Population (in %) in Botswana?
Ensure brevity in your answer.  2.67. What is the difference between the highest and the lowest Population (in %) in Cyprus?
Offer a terse response. 2.45. 